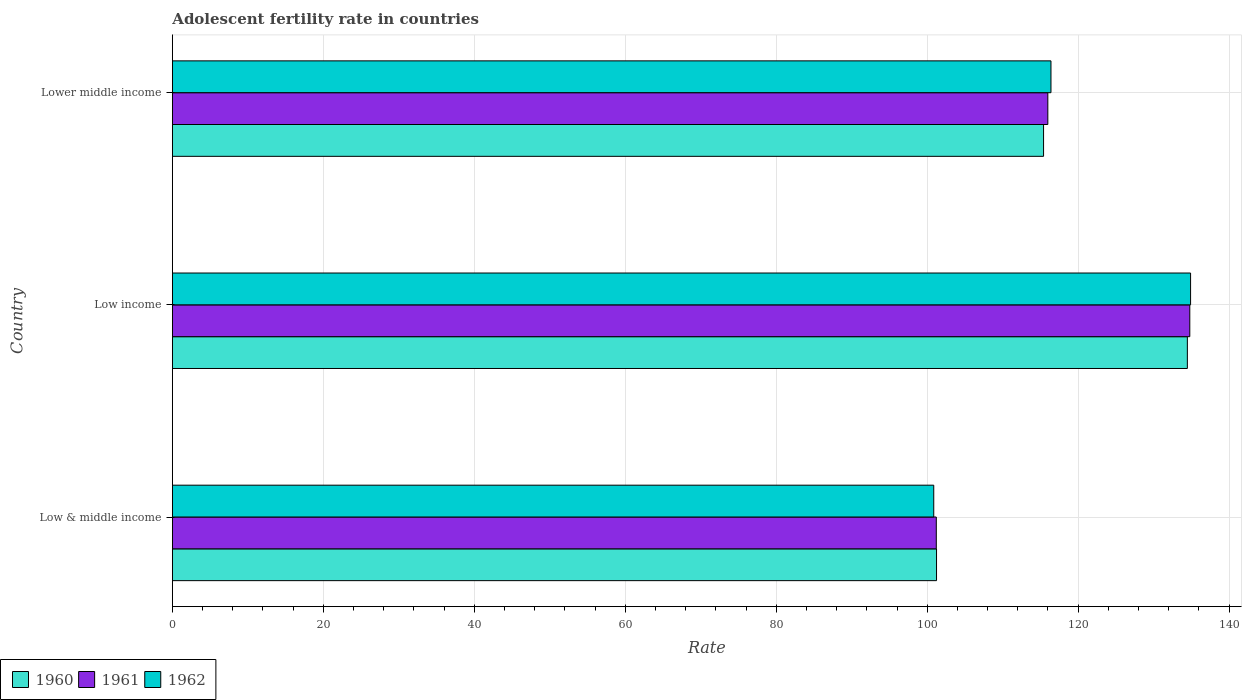How many groups of bars are there?
Make the answer very short. 3. What is the label of the 3rd group of bars from the top?
Provide a short and direct response. Low & middle income. In how many cases, is the number of bars for a given country not equal to the number of legend labels?
Keep it short and to the point. 0. What is the adolescent fertility rate in 1961 in Low income?
Your response must be concise. 134.79. Across all countries, what is the maximum adolescent fertility rate in 1961?
Provide a succinct answer. 134.79. Across all countries, what is the minimum adolescent fertility rate in 1962?
Give a very brief answer. 100.87. What is the total adolescent fertility rate in 1961 in the graph?
Offer a terse response. 351.98. What is the difference between the adolescent fertility rate in 1960 in Low income and that in Lower middle income?
Give a very brief answer. 19.05. What is the difference between the adolescent fertility rate in 1962 in Lower middle income and the adolescent fertility rate in 1960 in Low income?
Your answer should be compact. -18.07. What is the average adolescent fertility rate in 1962 per country?
Offer a very short reply. 117.39. What is the difference between the adolescent fertility rate in 1960 and adolescent fertility rate in 1962 in Low income?
Your answer should be very brief. -0.43. What is the ratio of the adolescent fertility rate in 1961 in Low & middle income to that in Low income?
Your answer should be compact. 0.75. Is the difference between the adolescent fertility rate in 1960 in Low & middle income and Low income greater than the difference between the adolescent fertility rate in 1962 in Low & middle income and Low income?
Offer a terse response. Yes. What is the difference between the highest and the second highest adolescent fertility rate in 1961?
Offer a very short reply. 18.81. What is the difference between the highest and the lowest adolescent fertility rate in 1961?
Your response must be concise. 33.59. Is the sum of the adolescent fertility rate in 1962 in Low & middle income and Low income greater than the maximum adolescent fertility rate in 1961 across all countries?
Keep it short and to the point. Yes. What does the 2nd bar from the top in Low & middle income represents?
Your response must be concise. 1961. What does the 2nd bar from the bottom in Low & middle income represents?
Your answer should be compact. 1961. Is it the case that in every country, the sum of the adolescent fertility rate in 1961 and adolescent fertility rate in 1962 is greater than the adolescent fertility rate in 1960?
Offer a very short reply. Yes. How many bars are there?
Make the answer very short. 9. Are all the bars in the graph horizontal?
Your answer should be compact. Yes. What is the difference between two consecutive major ticks on the X-axis?
Keep it short and to the point. 20. Are the values on the major ticks of X-axis written in scientific E-notation?
Offer a very short reply. No. Where does the legend appear in the graph?
Keep it short and to the point. Bottom left. What is the title of the graph?
Keep it short and to the point. Adolescent fertility rate in countries. Does "1969" appear as one of the legend labels in the graph?
Your response must be concise. No. What is the label or title of the X-axis?
Ensure brevity in your answer.  Rate. What is the label or title of the Y-axis?
Keep it short and to the point. Country. What is the Rate of 1960 in Low & middle income?
Your answer should be very brief. 101.24. What is the Rate of 1961 in Low & middle income?
Offer a terse response. 101.21. What is the Rate in 1962 in Low & middle income?
Give a very brief answer. 100.87. What is the Rate in 1960 in Low income?
Provide a succinct answer. 134.47. What is the Rate in 1961 in Low income?
Provide a short and direct response. 134.79. What is the Rate in 1962 in Low income?
Offer a terse response. 134.9. What is the Rate in 1960 in Lower middle income?
Your response must be concise. 115.42. What is the Rate in 1961 in Lower middle income?
Provide a succinct answer. 115.98. What is the Rate of 1962 in Lower middle income?
Your answer should be compact. 116.4. Across all countries, what is the maximum Rate of 1960?
Offer a terse response. 134.47. Across all countries, what is the maximum Rate of 1961?
Your answer should be compact. 134.79. Across all countries, what is the maximum Rate of 1962?
Your answer should be very brief. 134.9. Across all countries, what is the minimum Rate in 1960?
Your answer should be very brief. 101.24. Across all countries, what is the minimum Rate of 1961?
Your response must be concise. 101.21. Across all countries, what is the minimum Rate of 1962?
Give a very brief answer. 100.87. What is the total Rate in 1960 in the graph?
Give a very brief answer. 351.12. What is the total Rate in 1961 in the graph?
Your response must be concise. 351.98. What is the total Rate in 1962 in the graph?
Ensure brevity in your answer.  352.17. What is the difference between the Rate of 1960 in Low & middle income and that in Low income?
Offer a terse response. -33.23. What is the difference between the Rate in 1961 in Low & middle income and that in Low income?
Provide a succinct answer. -33.59. What is the difference between the Rate in 1962 in Low & middle income and that in Low income?
Offer a very short reply. -34.03. What is the difference between the Rate in 1960 in Low & middle income and that in Lower middle income?
Offer a terse response. -14.18. What is the difference between the Rate of 1961 in Low & middle income and that in Lower middle income?
Offer a terse response. -14.78. What is the difference between the Rate of 1962 in Low & middle income and that in Lower middle income?
Give a very brief answer. -15.53. What is the difference between the Rate in 1960 in Low income and that in Lower middle income?
Offer a very short reply. 19.05. What is the difference between the Rate in 1961 in Low income and that in Lower middle income?
Ensure brevity in your answer.  18.81. What is the difference between the Rate in 1962 in Low income and that in Lower middle income?
Keep it short and to the point. 18.5. What is the difference between the Rate in 1960 in Low & middle income and the Rate in 1961 in Low income?
Provide a succinct answer. -33.55. What is the difference between the Rate of 1960 in Low & middle income and the Rate of 1962 in Low income?
Provide a short and direct response. -33.66. What is the difference between the Rate in 1961 in Low & middle income and the Rate in 1962 in Low income?
Your response must be concise. -33.69. What is the difference between the Rate in 1960 in Low & middle income and the Rate in 1961 in Lower middle income?
Provide a succinct answer. -14.75. What is the difference between the Rate in 1960 in Low & middle income and the Rate in 1962 in Lower middle income?
Give a very brief answer. -15.16. What is the difference between the Rate of 1961 in Low & middle income and the Rate of 1962 in Lower middle income?
Make the answer very short. -15.19. What is the difference between the Rate in 1960 in Low income and the Rate in 1961 in Lower middle income?
Offer a terse response. 18.49. What is the difference between the Rate in 1960 in Low income and the Rate in 1962 in Lower middle income?
Keep it short and to the point. 18.07. What is the difference between the Rate in 1961 in Low income and the Rate in 1962 in Lower middle income?
Your response must be concise. 18.39. What is the average Rate of 1960 per country?
Ensure brevity in your answer.  117.04. What is the average Rate of 1961 per country?
Your answer should be compact. 117.33. What is the average Rate of 1962 per country?
Offer a terse response. 117.39. What is the difference between the Rate of 1960 and Rate of 1961 in Low & middle income?
Offer a terse response. 0.03. What is the difference between the Rate of 1960 and Rate of 1962 in Low & middle income?
Keep it short and to the point. 0.37. What is the difference between the Rate of 1961 and Rate of 1962 in Low & middle income?
Offer a terse response. 0.34. What is the difference between the Rate in 1960 and Rate in 1961 in Low income?
Your response must be concise. -0.32. What is the difference between the Rate in 1960 and Rate in 1962 in Low income?
Offer a very short reply. -0.43. What is the difference between the Rate in 1961 and Rate in 1962 in Low income?
Your response must be concise. -0.1. What is the difference between the Rate of 1960 and Rate of 1961 in Lower middle income?
Ensure brevity in your answer.  -0.57. What is the difference between the Rate of 1960 and Rate of 1962 in Lower middle income?
Your response must be concise. -0.98. What is the difference between the Rate in 1961 and Rate in 1962 in Lower middle income?
Your response must be concise. -0.42. What is the ratio of the Rate in 1960 in Low & middle income to that in Low income?
Give a very brief answer. 0.75. What is the ratio of the Rate of 1961 in Low & middle income to that in Low income?
Your response must be concise. 0.75. What is the ratio of the Rate of 1962 in Low & middle income to that in Low income?
Provide a succinct answer. 0.75. What is the ratio of the Rate in 1960 in Low & middle income to that in Lower middle income?
Ensure brevity in your answer.  0.88. What is the ratio of the Rate of 1961 in Low & middle income to that in Lower middle income?
Offer a terse response. 0.87. What is the ratio of the Rate in 1962 in Low & middle income to that in Lower middle income?
Offer a terse response. 0.87. What is the ratio of the Rate of 1960 in Low income to that in Lower middle income?
Keep it short and to the point. 1.17. What is the ratio of the Rate of 1961 in Low income to that in Lower middle income?
Offer a terse response. 1.16. What is the ratio of the Rate in 1962 in Low income to that in Lower middle income?
Offer a terse response. 1.16. What is the difference between the highest and the second highest Rate of 1960?
Make the answer very short. 19.05. What is the difference between the highest and the second highest Rate in 1961?
Give a very brief answer. 18.81. What is the difference between the highest and the second highest Rate of 1962?
Your response must be concise. 18.5. What is the difference between the highest and the lowest Rate in 1960?
Make the answer very short. 33.23. What is the difference between the highest and the lowest Rate of 1961?
Offer a very short reply. 33.59. What is the difference between the highest and the lowest Rate of 1962?
Keep it short and to the point. 34.03. 